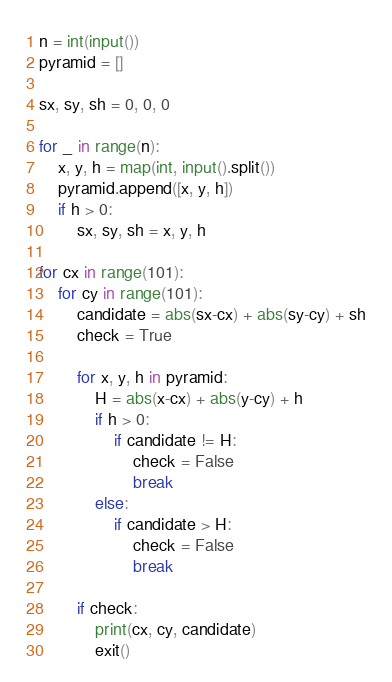<code> <loc_0><loc_0><loc_500><loc_500><_Python_>n = int(input())
pyramid = []

sx, sy, sh = 0, 0, 0

for _ in range(n):
    x, y, h = map(int, input().split())
    pyramid.append([x, y, h])
    if h > 0:
        sx, sy, sh = x, y, h

for cx in range(101):
    for cy in range(101):
        candidate = abs(sx-cx) + abs(sy-cy) + sh
        check = True

        for x, y, h in pyramid:
            H = abs(x-cx) + abs(y-cy) + h
            if h > 0:
                if candidate != H:
                    check = False
                    break
            else:
                if candidate > H:
                    check = False
                    break

        if check:
            print(cx, cy, candidate)
            exit()
</code> 